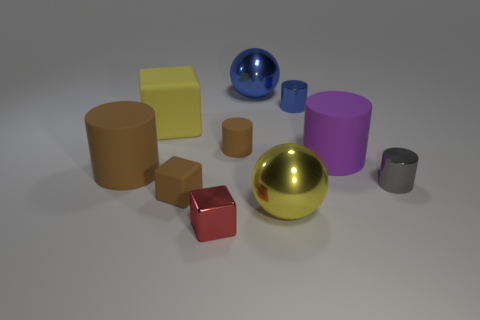Are there any small objects in front of the block left of the rubber object in front of the gray metallic cylinder?
Your response must be concise. Yes. The small cylinder that is the same material as the tiny brown block is what color?
Your answer should be compact. Brown. There is a big rubber cylinder in front of the purple object; is it the same color as the tiny matte cylinder?
Give a very brief answer. Yes. How many cylinders are either red metal objects or gray objects?
Provide a short and direct response. 1. What size is the shiny ball in front of the thing on the right side of the large rubber thing to the right of the tiny red metallic block?
Ensure brevity in your answer.  Large. The yellow rubber thing that is the same size as the purple cylinder is what shape?
Ensure brevity in your answer.  Cube. The large brown thing has what shape?
Your answer should be compact. Cylinder. Is the material of the large object behind the big block the same as the tiny red block?
Keep it short and to the point. Yes. How big is the blue object that is left of the big yellow metallic thing that is in front of the purple object?
Provide a succinct answer. Large. The shiny thing that is both in front of the yellow block and to the right of the big yellow shiny object is what color?
Your answer should be compact. Gray. 